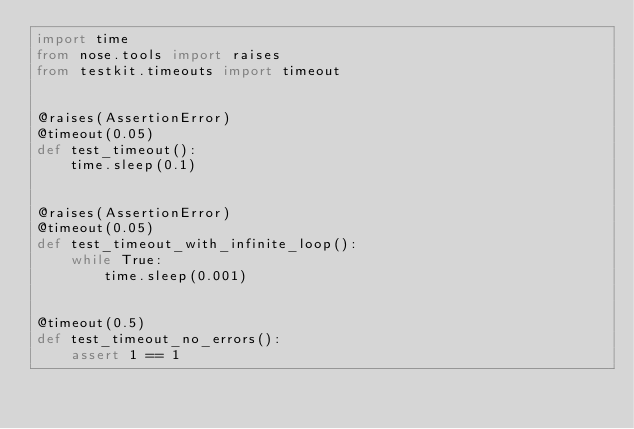Convert code to text. <code><loc_0><loc_0><loc_500><loc_500><_Python_>import time
from nose.tools import raises
from testkit.timeouts import timeout


@raises(AssertionError)
@timeout(0.05)
def test_timeout():
    time.sleep(0.1)


@raises(AssertionError)
@timeout(0.05)
def test_timeout_with_infinite_loop():
    while True:
        time.sleep(0.001)


@timeout(0.5)
def test_timeout_no_errors():
    assert 1 == 1
</code> 